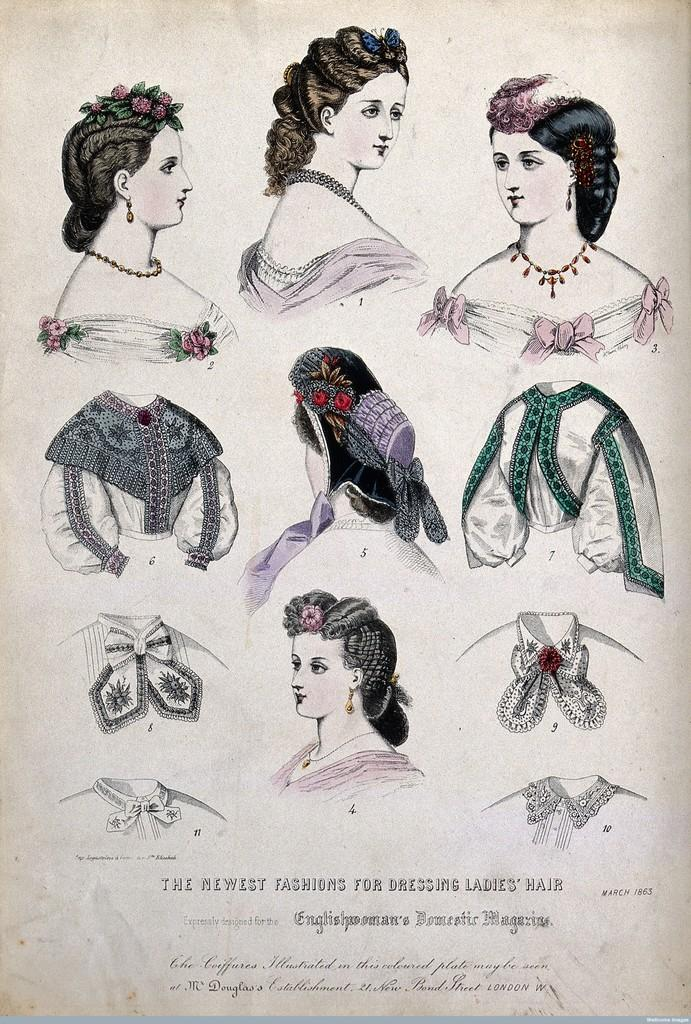What is depicted in the image? There is a sketch of people in the image. What can be seen on the people in the sketch? The sketch includes clothes. What is the medium of the sketch? The sketch is on a paper. Are there any words or letters in the image? Yes, there is text in the image. What type of honey is being served to the queen in the image? There is no queen or honey present in the image; it features a sketch of people with clothes and text on a paper. 